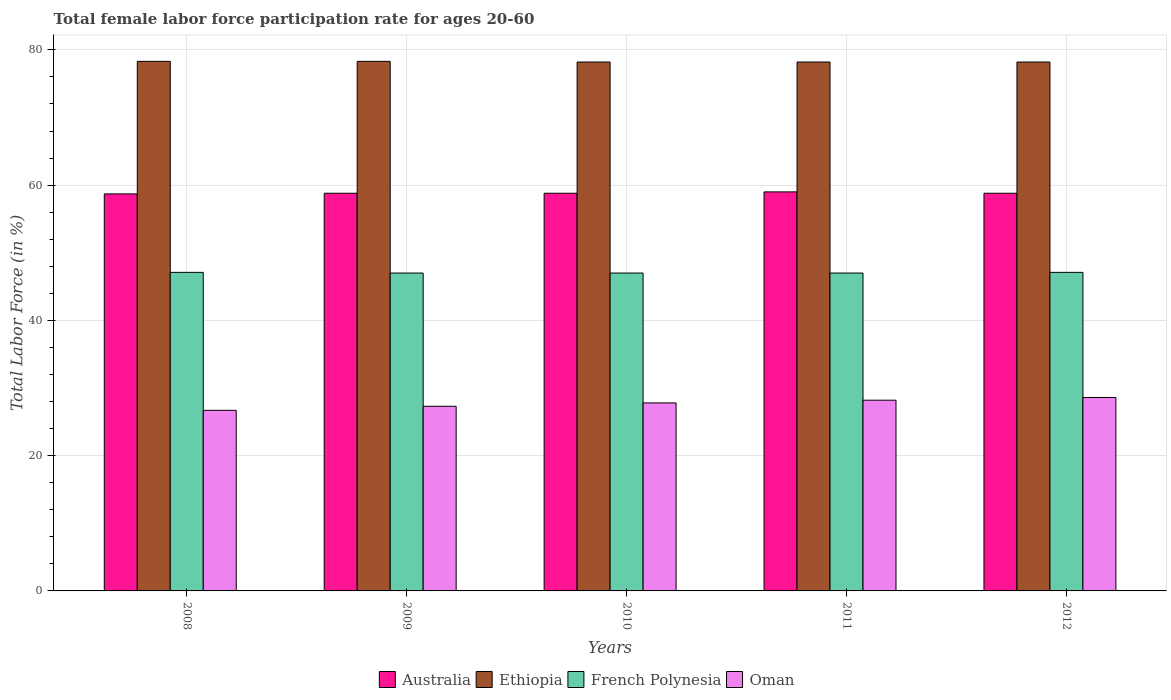How many groups of bars are there?
Keep it short and to the point. 5. How many bars are there on the 2nd tick from the right?
Provide a succinct answer. 4. What is the label of the 3rd group of bars from the left?
Ensure brevity in your answer.  2010. What is the female labor force participation rate in Australia in 2009?
Keep it short and to the point. 58.8. Across all years, what is the maximum female labor force participation rate in Ethiopia?
Your answer should be very brief. 78.3. Across all years, what is the minimum female labor force participation rate in French Polynesia?
Your response must be concise. 47. In which year was the female labor force participation rate in Oman maximum?
Give a very brief answer. 2012. In which year was the female labor force participation rate in French Polynesia minimum?
Make the answer very short. 2009. What is the total female labor force participation rate in Australia in the graph?
Make the answer very short. 294.1. What is the difference between the female labor force participation rate in Oman in 2009 and that in 2011?
Your response must be concise. -0.9. What is the difference between the female labor force participation rate in French Polynesia in 2008 and the female labor force participation rate in Australia in 2010?
Ensure brevity in your answer.  -11.7. What is the average female labor force participation rate in Australia per year?
Your answer should be compact. 58.82. In the year 2012, what is the difference between the female labor force participation rate in Australia and female labor force participation rate in Oman?
Give a very brief answer. 30.2. In how many years, is the female labor force participation rate in Oman greater than 36 %?
Give a very brief answer. 0. What is the difference between the highest and the lowest female labor force participation rate in Oman?
Offer a terse response. 1.9. In how many years, is the female labor force participation rate in Australia greater than the average female labor force participation rate in Australia taken over all years?
Ensure brevity in your answer.  1. Is the sum of the female labor force participation rate in Ethiopia in 2010 and 2012 greater than the maximum female labor force participation rate in Australia across all years?
Provide a succinct answer. Yes. What does the 3rd bar from the left in 2012 represents?
Offer a terse response. French Polynesia. What does the 2nd bar from the right in 2008 represents?
Ensure brevity in your answer.  French Polynesia. Is it the case that in every year, the sum of the female labor force participation rate in French Polynesia and female labor force participation rate in Oman is greater than the female labor force participation rate in Ethiopia?
Your answer should be very brief. No. Are all the bars in the graph horizontal?
Offer a terse response. No. How many years are there in the graph?
Offer a terse response. 5. What is the difference between two consecutive major ticks on the Y-axis?
Your answer should be very brief. 20. How many legend labels are there?
Keep it short and to the point. 4. How are the legend labels stacked?
Keep it short and to the point. Horizontal. What is the title of the graph?
Make the answer very short. Total female labor force participation rate for ages 20-60. Does "Nepal" appear as one of the legend labels in the graph?
Offer a terse response. No. What is the label or title of the X-axis?
Your response must be concise. Years. What is the label or title of the Y-axis?
Your answer should be compact. Total Labor Force (in %). What is the Total Labor Force (in %) of Australia in 2008?
Your answer should be very brief. 58.7. What is the Total Labor Force (in %) in Ethiopia in 2008?
Provide a succinct answer. 78.3. What is the Total Labor Force (in %) in French Polynesia in 2008?
Your answer should be very brief. 47.1. What is the Total Labor Force (in %) of Oman in 2008?
Offer a terse response. 26.7. What is the Total Labor Force (in %) in Australia in 2009?
Make the answer very short. 58.8. What is the Total Labor Force (in %) in Ethiopia in 2009?
Your response must be concise. 78.3. What is the Total Labor Force (in %) in Oman in 2009?
Ensure brevity in your answer.  27.3. What is the Total Labor Force (in %) of Australia in 2010?
Your answer should be compact. 58.8. What is the Total Labor Force (in %) of Ethiopia in 2010?
Give a very brief answer. 78.2. What is the Total Labor Force (in %) in French Polynesia in 2010?
Provide a short and direct response. 47. What is the Total Labor Force (in %) of Oman in 2010?
Provide a short and direct response. 27.8. What is the Total Labor Force (in %) in Australia in 2011?
Provide a succinct answer. 59. What is the Total Labor Force (in %) in Ethiopia in 2011?
Your answer should be very brief. 78.2. What is the Total Labor Force (in %) of French Polynesia in 2011?
Give a very brief answer. 47. What is the Total Labor Force (in %) in Oman in 2011?
Give a very brief answer. 28.2. What is the Total Labor Force (in %) of Australia in 2012?
Your answer should be compact. 58.8. What is the Total Labor Force (in %) in Ethiopia in 2012?
Your answer should be compact. 78.2. What is the Total Labor Force (in %) of French Polynesia in 2012?
Your response must be concise. 47.1. What is the Total Labor Force (in %) in Oman in 2012?
Ensure brevity in your answer.  28.6. Across all years, what is the maximum Total Labor Force (in %) of Ethiopia?
Give a very brief answer. 78.3. Across all years, what is the maximum Total Labor Force (in %) in French Polynesia?
Provide a succinct answer. 47.1. Across all years, what is the maximum Total Labor Force (in %) of Oman?
Offer a very short reply. 28.6. Across all years, what is the minimum Total Labor Force (in %) of Australia?
Ensure brevity in your answer.  58.7. Across all years, what is the minimum Total Labor Force (in %) in Ethiopia?
Your response must be concise. 78.2. Across all years, what is the minimum Total Labor Force (in %) of Oman?
Provide a short and direct response. 26.7. What is the total Total Labor Force (in %) of Australia in the graph?
Keep it short and to the point. 294.1. What is the total Total Labor Force (in %) of Ethiopia in the graph?
Give a very brief answer. 391.2. What is the total Total Labor Force (in %) in French Polynesia in the graph?
Give a very brief answer. 235.2. What is the total Total Labor Force (in %) in Oman in the graph?
Your answer should be compact. 138.6. What is the difference between the Total Labor Force (in %) in Australia in 2008 and that in 2009?
Provide a short and direct response. -0.1. What is the difference between the Total Labor Force (in %) of Oman in 2008 and that in 2009?
Ensure brevity in your answer.  -0.6. What is the difference between the Total Labor Force (in %) in Ethiopia in 2008 and that in 2010?
Ensure brevity in your answer.  0.1. What is the difference between the Total Labor Force (in %) of Australia in 2008 and that in 2011?
Your answer should be compact. -0.3. What is the difference between the Total Labor Force (in %) in Ethiopia in 2008 and that in 2011?
Your answer should be very brief. 0.1. What is the difference between the Total Labor Force (in %) in French Polynesia in 2008 and that in 2011?
Offer a very short reply. 0.1. What is the difference between the Total Labor Force (in %) in French Polynesia in 2008 and that in 2012?
Offer a very short reply. 0. What is the difference between the Total Labor Force (in %) in Oman in 2008 and that in 2012?
Keep it short and to the point. -1.9. What is the difference between the Total Labor Force (in %) of Ethiopia in 2009 and that in 2010?
Ensure brevity in your answer.  0.1. What is the difference between the Total Labor Force (in %) in Oman in 2009 and that in 2010?
Offer a very short reply. -0.5. What is the difference between the Total Labor Force (in %) in Australia in 2009 and that in 2011?
Provide a short and direct response. -0.2. What is the difference between the Total Labor Force (in %) in French Polynesia in 2009 and that in 2011?
Make the answer very short. 0. What is the difference between the Total Labor Force (in %) of Oman in 2009 and that in 2011?
Give a very brief answer. -0.9. What is the difference between the Total Labor Force (in %) of Australia in 2009 and that in 2012?
Offer a very short reply. 0. What is the difference between the Total Labor Force (in %) in Ethiopia in 2009 and that in 2012?
Ensure brevity in your answer.  0.1. What is the difference between the Total Labor Force (in %) in French Polynesia in 2009 and that in 2012?
Offer a terse response. -0.1. What is the difference between the Total Labor Force (in %) in Oman in 2009 and that in 2012?
Keep it short and to the point. -1.3. What is the difference between the Total Labor Force (in %) of Ethiopia in 2010 and that in 2011?
Offer a terse response. 0. What is the difference between the Total Labor Force (in %) in Australia in 2010 and that in 2012?
Provide a succinct answer. 0. What is the difference between the Total Labor Force (in %) of Ethiopia in 2010 and that in 2012?
Your answer should be compact. 0. What is the difference between the Total Labor Force (in %) in French Polynesia in 2010 and that in 2012?
Provide a short and direct response. -0.1. What is the difference between the Total Labor Force (in %) of Oman in 2010 and that in 2012?
Ensure brevity in your answer.  -0.8. What is the difference between the Total Labor Force (in %) of Australia in 2011 and that in 2012?
Provide a succinct answer. 0.2. What is the difference between the Total Labor Force (in %) of French Polynesia in 2011 and that in 2012?
Provide a short and direct response. -0.1. What is the difference between the Total Labor Force (in %) in Oman in 2011 and that in 2012?
Provide a succinct answer. -0.4. What is the difference between the Total Labor Force (in %) of Australia in 2008 and the Total Labor Force (in %) of Ethiopia in 2009?
Offer a terse response. -19.6. What is the difference between the Total Labor Force (in %) of Australia in 2008 and the Total Labor Force (in %) of Oman in 2009?
Give a very brief answer. 31.4. What is the difference between the Total Labor Force (in %) of Ethiopia in 2008 and the Total Labor Force (in %) of French Polynesia in 2009?
Ensure brevity in your answer.  31.3. What is the difference between the Total Labor Force (in %) of French Polynesia in 2008 and the Total Labor Force (in %) of Oman in 2009?
Give a very brief answer. 19.8. What is the difference between the Total Labor Force (in %) of Australia in 2008 and the Total Labor Force (in %) of Ethiopia in 2010?
Make the answer very short. -19.5. What is the difference between the Total Labor Force (in %) of Australia in 2008 and the Total Labor Force (in %) of French Polynesia in 2010?
Offer a terse response. 11.7. What is the difference between the Total Labor Force (in %) in Australia in 2008 and the Total Labor Force (in %) in Oman in 2010?
Give a very brief answer. 30.9. What is the difference between the Total Labor Force (in %) in Ethiopia in 2008 and the Total Labor Force (in %) in French Polynesia in 2010?
Offer a very short reply. 31.3. What is the difference between the Total Labor Force (in %) of Ethiopia in 2008 and the Total Labor Force (in %) of Oman in 2010?
Your response must be concise. 50.5. What is the difference between the Total Labor Force (in %) in French Polynesia in 2008 and the Total Labor Force (in %) in Oman in 2010?
Provide a succinct answer. 19.3. What is the difference between the Total Labor Force (in %) of Australia in 2008 and the Total Labor Force (in %) of Ethiopia in 2011?
Ensure brevity in your answer.  -19.5. What is the difference between the Total Labor Force (in %) in Australia in 2008 and the Total Labor Force (in %) in Oman in 2011?
Your answer should be very brief. 30.5. What is the difference between the Total Labor Force (in %) in Ethiopia in 2008 and the Total Labor Force (in %) in French Polynesia in 2011?
Your answer should be compact. 31.3. What is the difference between the Total Labor Force (in %) in Ethiopia in 2008 and the Total Labor Force (in %) in Oman in 2011?
Provide a succinct answer. 50.1. What is the difference between the Total Labor Force (in %) in Australia in 2008 and the Total Labor Force (in %) in Ethiopia in 2012?
Your answer should be very brief. -19.5. What is the difference between the Total Labor Force (in %) of Australia in 2008 and the Total Labor Force (in %) of French Polynesia in 2012?
Keep it short and to the point. 11.6. What is the difference between the Total Labor Force (in %) in Australia in 2008 and the Total Labor Force (in %) in Oman in 2012?
Your response must be concise. 30.1. What is the difference between the Total Labor Force (in %) of Ethiopia in 2008 and the Total Labor Force (in %) of French Polynesia in 2012?
Provide a succinct answer. 31.2. What is the difference between the Total Labor Force (in %) of Ethiopia in 2008 and the Total Labor Force (in %) of Oman in 2012?
Your answer should be compact. 49.7. What is the difference between the Total Labor Force (in %) of Australia in 2009 and the Total Labor Force (in %) of Ethiopia in 2010?
Your answer should be compact. -19.4. What is the difference between the Total Labor Force (in %) of Ethiopia in 2009 and the Total Labor Force (in %) of French Polynesia in 2010?
Offer a terse response. 31.3. What is the difference between the Total Labor Force (in %) of Ethiopia in 2009 and the Total Labor Force (in %) of Oman in 2010?
Provide a short and direct response. 50.5. What is the difference between the Total Labor Force (in %) of French Polynesia in 2009 and the Total Labor Force (in %) of Oman in 2010?
Give a very brief answer. 19.2. What is the difference between the Total Labor Force (in %) in Australia in 2009 and the Total Labor Force (in %) in Ethiopia in 2011?
Offer a very short reply. -19.4. What is the difference between the Total Labor Force (in %) in Australia in 2009 and the Total Labor Force (in %) in Oman in 2011?
Your answer should be compact. 30.6. What is the difference between the Total Labor Force (in %) of Ethiopia in 2009 and the Total Labor Force (in %) of French Polynesia in 2011?
Your answer should be compact. 31.3. What is the difference between the Total Labor Force (in %) of Ethiopia in 2009 and the Total Labor Force (in %) of Oman in 2011?
Keep it short and to the point. 50.1. What is the difference between the Total Labor Force (in %) of Australia in 2009 and the Total Labor Force (in %) of Ethiopia in 2012?
Your response must be concise. -19.4. What is the difference between the Total Labor Force (in %) in Australia in 2009 and the Total Labor Force (in %) in French Polynesia in 2012?
Your answer should be compact. 11.7. What is the difference between the Total Labor Force (in %) in Australia in 2009 and the Total Labor Force (in %) in Oman in 2012?
Make the answer very short. 30.2. What is the difference between the Total Labor Force (in %) of Ethiopia in 2009 and the Total Labor Force (in %) of French Polynesia in 2012?
Provide a succinct answer. 31.2. What is the difference between the Total Labor Force (in %) of Ethiopia in 2009 and the Total Labor Force (in %) of Oman in 2012?
Your response must be concise. 49.7. What is the difference between the Total Labor Force (in %) in French Polynesia in 2009 and the Total Labor Force (in %) in Oman in 2012?
Give a very brief answer. 18.4. What is the difference between the Total Labor Force (in %) of Australia in 2010 and the Total Labor Force (in %) of Ethiopia in 2011?
Your answer should be compact. -19.4. What is the difference between the Total Labor Force (in %) of Australia in 2010 and the Total Labor Force (in %) of French Polynesia in 2011?
Offer a very short reply. 11.8. What is the difference between the Total Labor Force (in %) in Australia in 2010 and the Total Labor Force (in %) in Oman in 2011?
Offer a terse response. 30.6. What is the difference between the Total Labor Force (in %) of Ethiopia in 2010 and the Total Labor Force (in %) of French Polynesia in 2011?
Ensure brevity in your answer.  31.2. What is the difference between the Total Labor Force (in %) in French Polynesia in 2010 and the Total Labor Force (in %) in Oman in 2011?
Offer a very short reply. 18.8. What is the difference between the Total Labor Force (in %) of Australia in 2010 and the Total Labor Force (in %) of Ethiopia in 2012?
Keep it short and to the point. -19.4. What is the difference between the Total Labor Force (in %) in Australia in 2010 and the Total Labor Force (in %) in Oman in 2012?
Your answer should be very brief. 30.2. What is the difference between the Total Labor Force (in %) of Ethiopia in 2010 and the Total Labor Force (in %) of French Polynesia in 2012?
Offer a very short reply. 31.1. What is the difference between the Total Labor Force (in %) in Ethiopia in 2010 and the Total Labor Force (in %) in Oman in 2012?
Give a very brief answer. 49.6. What is the difference between the Total Labor Force (in %) of French Polynesia in 2010 and the Total Labor Force (in %) of Oman in 2012?
Offer a terse response. 18.4. What is the difference between the Total Labor Force (in %) of Australia in 2011 and the Total Labor Force (in %) of Ethiopia in 2012?
Provide a succinct answer. -19.2. What is the difference between the Total Labor Force (in %) in Australia in 2011 and the Total Labor Force (in %) in French Polynesia in 2012?
Keep it short and to the point. 11.9. What is the difference between the Total Labor Force (in %) of Australia in 2011 and the Total Labor Force (in %) of Oman in 2012?
Give a very brief answer. 30.4. What is the difference between the Total Labor Force (in %) in Ethiopia in 2011 and the Total Labor Force (in %) in French Polynesia in 2012?
Ensure brevity in your answer.  31.1. What is the difference between the Total Labor Force (in %) of Ethiopia in 2011 and the Total Labor Force (in %) of Oman in 2012?
Your answer should be compact. 49.6. What is the average Total Labor Force (in %) of Australia per year?
Offer a very short reply. 58.82. What is the average Total Labor Force (in %) in Ethiopia per year?
Ensure brevity in your answer.  78.24. What is the average Total Labor Force (in %) of French Polynesia per year?
Keep it short and to the point. 47.04. What is the average Total Labor Force (in %) of Oman per year?
Provide a short and direct response. 27.72. In the year 2008, what is the difference between the Total Labor Force (in %) in Australia and Total Labor Force (in %) in Ethiopia?
Make the answer very short. -19.6. In the year 2008, what is the difference between the Total Labor Force (in %) of Australia and Total Labor Force (in %) of French Polynesia?
Your answer should be compact. 11.6. In the year 2008, what is the difference between the Total Labor Force (in %) in Australia and Total Labor Force (in %) in Oman?
Give a very brief answer. 32. In the year 2008, what is the difference between the Total Labor Force (in %) in Ethiopia and Total Labor Force (in %) in French Polynesia?
Provide a short and direct response. 31.2. In the year 2008, what is the difference between the Total Labor Force (in %) in Ethiopia and Total Labor Force (in %) in Oman?
Provide a short and direct response. 51.6. In the year 2008, what is the difference between the Total Labor Force (in %) of French Polynesia and Total Labor Force (in %) of Oman?
Your answer should be compact. 20.4. In the year 2009, what is the difference between the Total Labor Force (in %) of Australia and Total Labor Force (in %) of Ethiopia?
Your answer should be compact. -19.5. In the year 2009, what is the difference between the Total Labor Force (in %) in Australia and Total Labor Force (in %) in Oman?
Give a very brief answer. 31.5. In the year 2009, what is the difference between the Total Labor Force (in %) in Ethiopia and Total Labor Force (in %) in French Polynesia?
Provide a short and direct response. 31.3. In the year 2010, what is the difference between the Total Labor Force (in %) of Australia and Total Labor Force (in %) of Ethiopia?
Offer a very short reply. -19.4. In the year 2010, what is the difference between the Total Labor Force (in %) of Ethiopia and Total Labor Force (in %) of French Polynesia?
Provide a succinct answer. 31.2. In the year 2010, what is the difference between the Total Labor Force (in %) in Ethiopia and Total Labor Force (in %) in Oman?
Ensure brevity in your answer.  50.4. In the year 2011, what is the difference between the Total Labor Force (in %) of Australia and Total Labor Force (in %) of Ethiopia?
Ensure brevity in your answer.  -19.2. In the year 2011, what is the difference between the Total Labor Force (in %) of Australia and Total Labor Force (in %) of French Polynesia?
Give a very brief answer. 12. In the year 2011, what is the difference between the Total Labor Force (in %) of Australia and Total Labor Force (in %) of Oman?
Offer a very short reply. 30.8. In the year 2011, what is the difference between the Total Labor Force (in %) of Ethiopia and Total Labor Force (in %) of French Polynesia?
Provide a short and direct response. 31.2. In the year 2012, what is the difference between the Total Labor Force (in %) of Australia and Total Labor Force (in %) of Ethiopia?
Offer a very short reply. -19.4. In the year 2012, what is the difference between the Total Labor Force (in %) of Australia and Total Labor Force (in %) of French Polynesia?
Make the answer very short. 11.7. In the year 2012, what is the difference between the Total Labor Force (in %) of Australia and Total Labor Force (in %) of Oman?
Provide a short and direct response. 30.2. In the year 2012, what is the difference between the Total Labor Force (in %) of Ethiopia and Total Labor Force (in %) of French Polynesia?
Provide a short and direct response. 31.1. In the year 2012, what is the difference between the Total Labor Force (in %) in Ethiopia and Total Labor Force (in %) in Oman?
Your answer should be compact. 49.6. In the year 2012, what is the difference between the Total Labor Force (in %) in French Polynesia and Total Labor Force (in %) in Oman?
Keep it short and to the point. 18.5. What is the ratio of the Total Labor Force (in %) of French Polynesia in 2008 to that in 2009?
Keep it short and to the point. 1. What is the ratio of the Total Labor Force (in %) of Oman in 2008 to that in 2009?
Your response must be concise. 0.98. What is the ratio of the Total Labor Force (in %) of Oman in 2008 to that in 2010?
Offer a terse response. 0.96. What is the ratio of the Total Labor Force (in %) of Oman in 2008 to that in 2011?
Your answer should be compact. 0.95. What is the ratio of the Total Labor Force (in %) in Ethiopia in 2008 to that in 2012?
Make the answer very short. 1. What is the ratio of the Total Labor Force (in %) of Oman in 2008 to that in 2012?
Make the answer very short. 0.93. What is the ratio of the Total Labor Force (in %) of Australia in 2009 to that in 2010?
Your response must be concise. 1. What is the ratio of the Total Labor Force (in %) in Ethiopia in 2009 to that in 2010?
Offer a very short reply. 1. What is the ratio of the Total Labor Force (in %) in Oman in 2009 to that in 2010?
Give a very brief answer. 0.98. What is the ratio of the Total Labor Force (in %) in Australia in 2009 to that in 2011?
Your answer should be very brief. 1. What is the ratio of the Total Labor Force (in %) of Oman in 2009 to that in 2011?
Make the answer very short. 0.97. What is the ratio of the Total Labor Force (in %) of Ethiopia in 2009 to that in 2012?
Your response must be concise. 1. What is the ratio of the Total Labor Force (in %) in Oman in 2009 to that in 2012?
Ensure brevity in your answer.  0.95. What is the ratio of the Total Labor Force (in %) of Australia in 2010 to that in 2011?
Ensure brevity in your answer.  1. What is the ratio of the Total Labor Force (in %) in Oman in 2010 to that in 2011?
Offer a very short reply. 0.99. What is the ratio of the Total Labor Force (in %) of Australia in 2010 to that in 2012?
Offer a very short reply. 1. What is the ratio of the Total Labor Force (in %) of Ethiopia in 2010 to that in 2012?
Offer a very short reply. 1. What is the ratio of the Total Labor Force (in %) in Oman in 2010 to that in 2012?
Make the answer very short. 0.97. What is the ratio of the Total Labor Force (in %) of Ethiopia in 2011 to that in 2012?
Offer a terse response. 1. What is the difference between the highest and the second highest Total Labor Force (in %) in Ethiopia?
Your response must be concise. 0. What is the difference between the highest and the lowest Total Labor Force (in %) of Ethiopia?
Offer a very short reply. 0.1. 